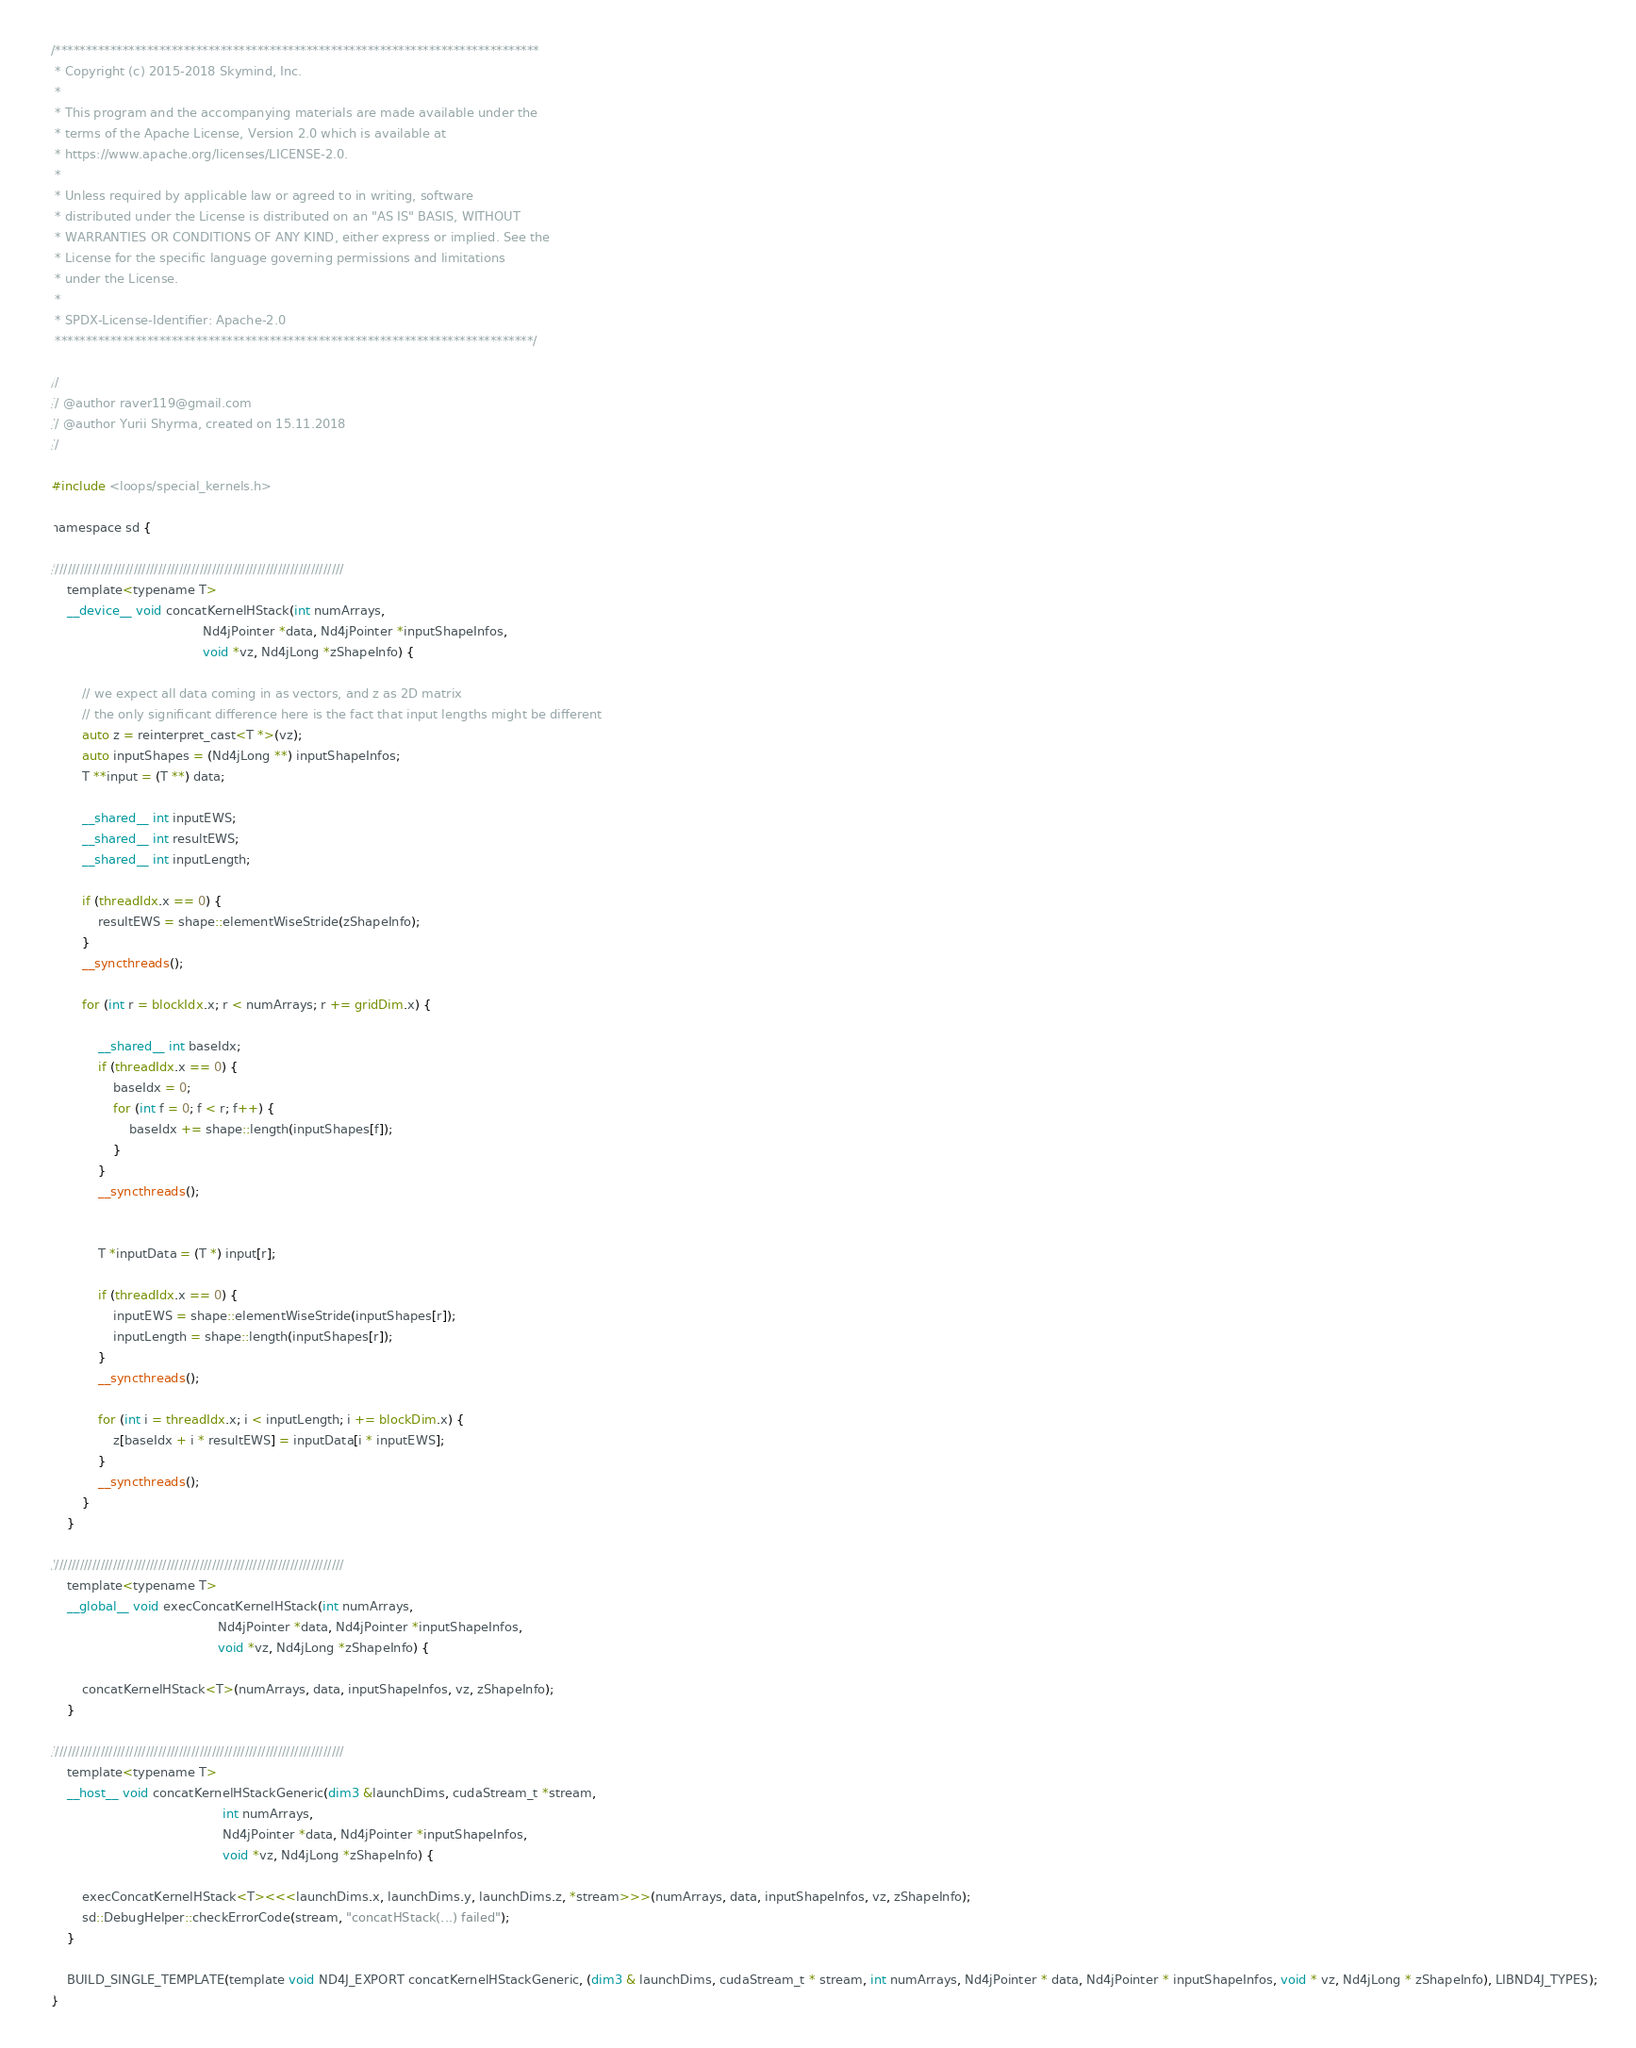Convert code to text. <code><loc_0><loc_0><loc_500><loc_500><_Cuda_>/*******************************************************************************
 * Copyright (c) 2015-2018 Skymind, Inc.
 *
 * This program and the accompanying materials are made available under the
 * terms of the Apache License, Version 2.0 which is available at
 * https://www.apache.org/licenses/LICENSE-2.0.
 *
 * Unless required by applicable law or agreed to in writing, software
 * distributed under the License is distributed on an "AS IS" BASIS, WITHOUT
 * WARRANTIES OR CONDITIONS OF ANY KIND, either express or implied. See the
 * License for the specific language governing permissions and limitations
 * under the License.
 *
 * SPDX-License-Identifier: Apache-2.0
 ******************************************************************************/

//
// @author raver119@gmail.com
// @author Yurii Shyrma, created on 15.11.2018
//

#include <loops/special_kernels.h>

namespace sd {

///////////////////////////////////////////////////////////////////////
    template<typename T>
    __device__ void concatKernelHStack(int numArrays,
                                       Nd4jPointer *data, Nd4jPointer *inputShapeInfos,
                                       void *vz, Nd4jLong *zShapeInfo) {

        // we expect all data coming in as vectors, and z as 2D matrix
        // the only significant difference here is the fact that input lengths might be different
        auto z = reinterpret_cast<T *>(vz);
        auto inputShapes = (Nd4jLong **) inputShapeInfos;
        T **input = (T **) data;

        __shared__ int inputEWS;
        __shared__ int resultEWS;
        __shared__ int inputLength;

        if (threadIdx.x == 0) {
            resultEWS = shape::elementWiseStride(zShapeInfo);
        }
        __syncthreads();

        for (int r = blockIdx.x; r < numArrays; r += gridDim.x) {

            __shared__ int baseIdx;
            if (threadIdx.x == 0) {
                baseIdx = 0;
                for (int f = 0; f < r; f++) {
                    baseIdx += shape::length(inputShapes[f]);
                }
            }
            __syncthreads();


            T *inputData = (T *) input[r];

            if (threadIdx.x == 0) {
                inputEWS = shape::elementWiseStride(inputShapes[r]);
                inputLength = shape::length(inputShapes[r]);
            }
            __syncthreads();

            for (int i = threadIdx.x; i < inputLength; i += blockDim.x) {
                z[baseIdx + i * resultEWS] = inputData[i * inputEWS];
            }
            __syncthreads();
        }
    }

///////////////////////////////////////////////////////////////////////
    template<typename T>
    __global__ void execConcatKernelHStack(int numArrays,
                                           Nd4jPointer *data, Nd4jPointer *inputShapeInfos,
                                           void *vz, Nd4jLong *zShapeInfo) {

        concatKernelHStack<T>(numArrays, data, inputShapeInfos, vz, zShapeInfo);
    }

///////////////////////////////////////////////////////////////////////
    template<typename T>
    __host__ void concatKernelHStackGeneric(dim3 &launchDims, cudaStream_t *stream,
                                            int numArrays,
                                            Nd4jPointer *data, Nd4jPointer *inputShapeInfos,
                                            void *vz, Nd4jLong *zShapeInfo) {

        execConcatKernelHStack<T><<<launchDims.x, launchDims.y, launchDims.z, *stream>>>(numArrays, data, inputShapeInfos, vz, zShapeInfo);
        sd::DebugHelper::checkErrorCode(stream, "concatHStack(...) failed");
    }

    BUILD_SINGLE_TEMPLATE(template void ND4J_EXPORT concatKernelHStackGeneric, (dim3 & launchDims, cudaStream_t * stream, int numArrays, Nd4jPointer * data, Nd4jPointer * inputShapeInfos, void * vz, Nd4jLong * zShapeInfo), LIBND4J_TYPES);
}</code> 